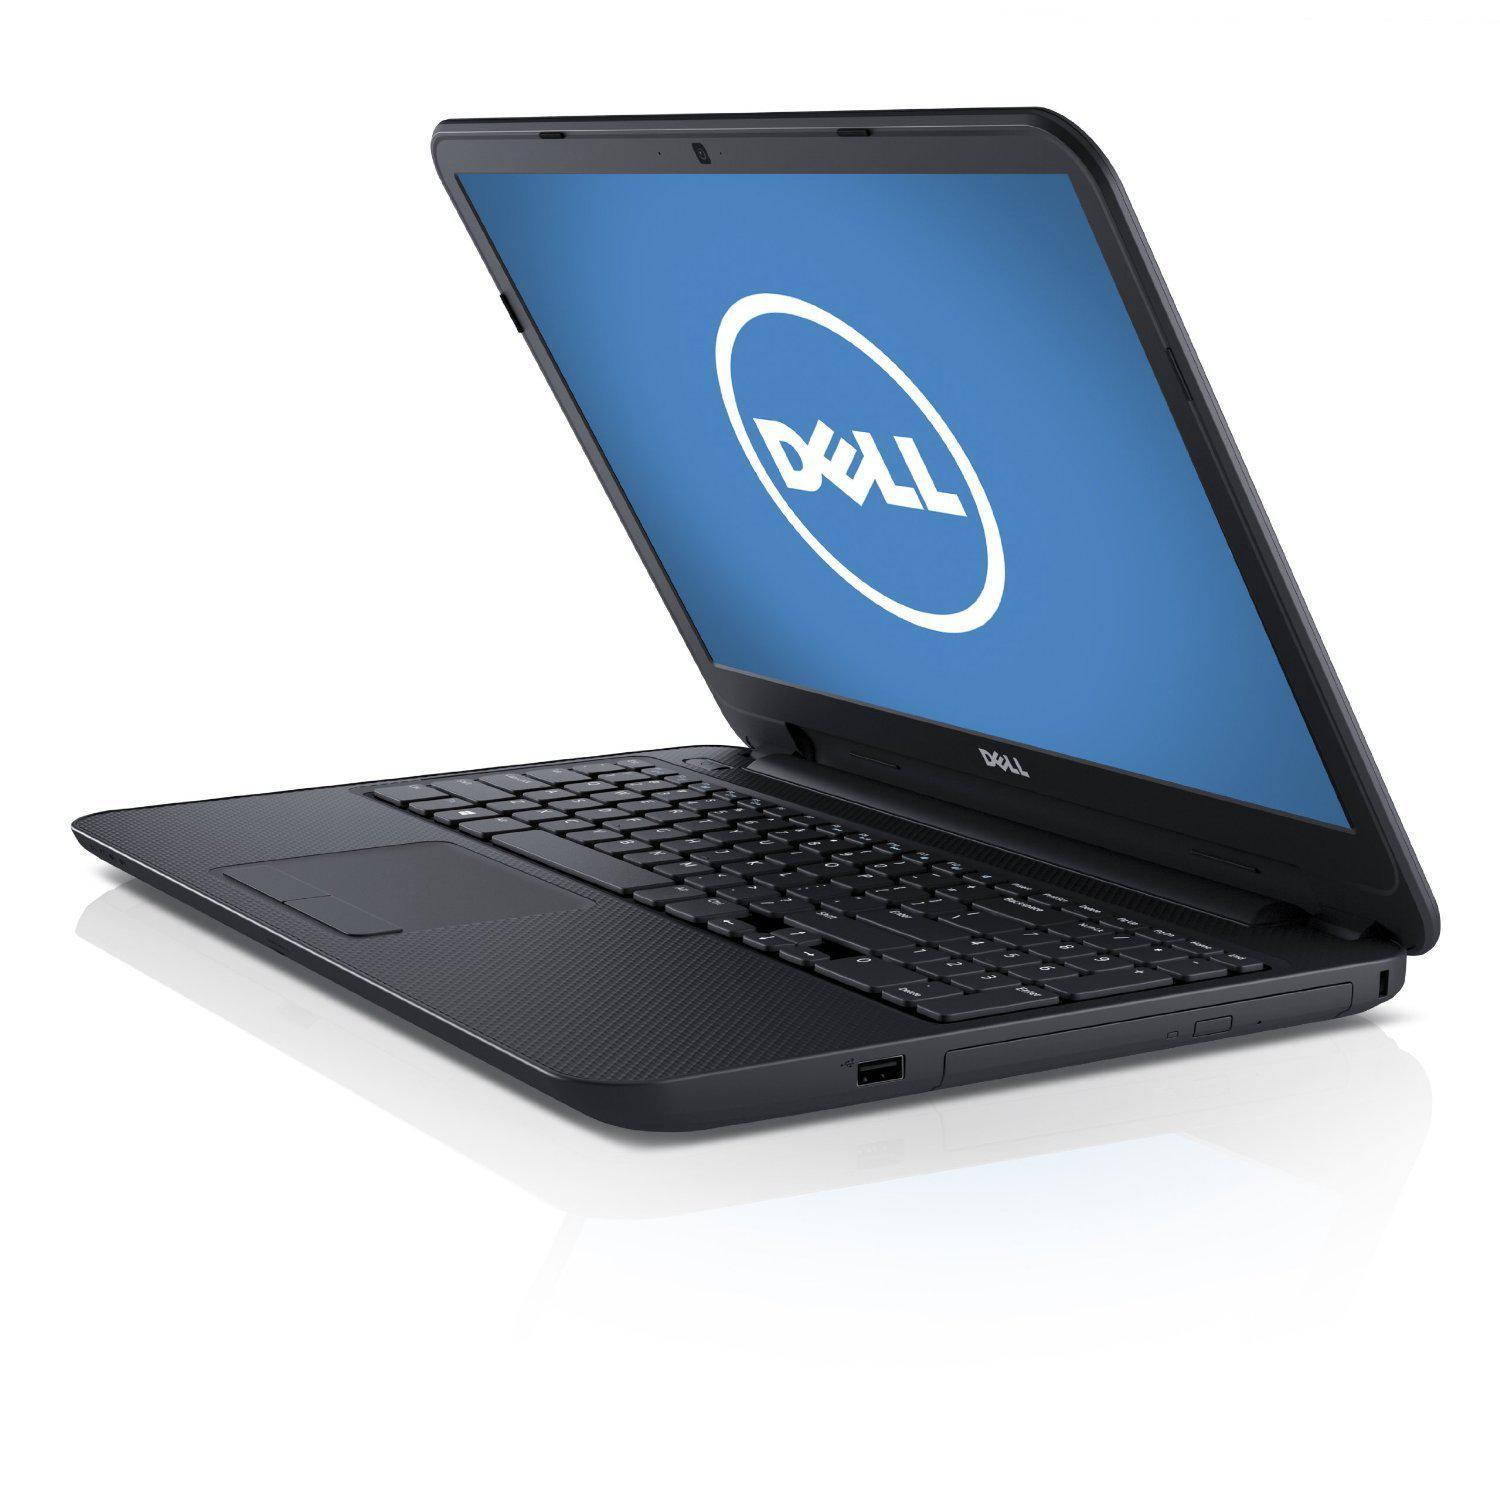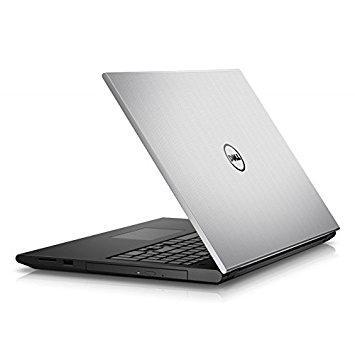The first image is the image on the left, the second image is the image on the right. Assess this claim about the two images: "All laptops are opened at less than a 90-degree angle, and at least one laptop has its back turned toward the camera.". Correct or not? Answer yes or no. Yes. 